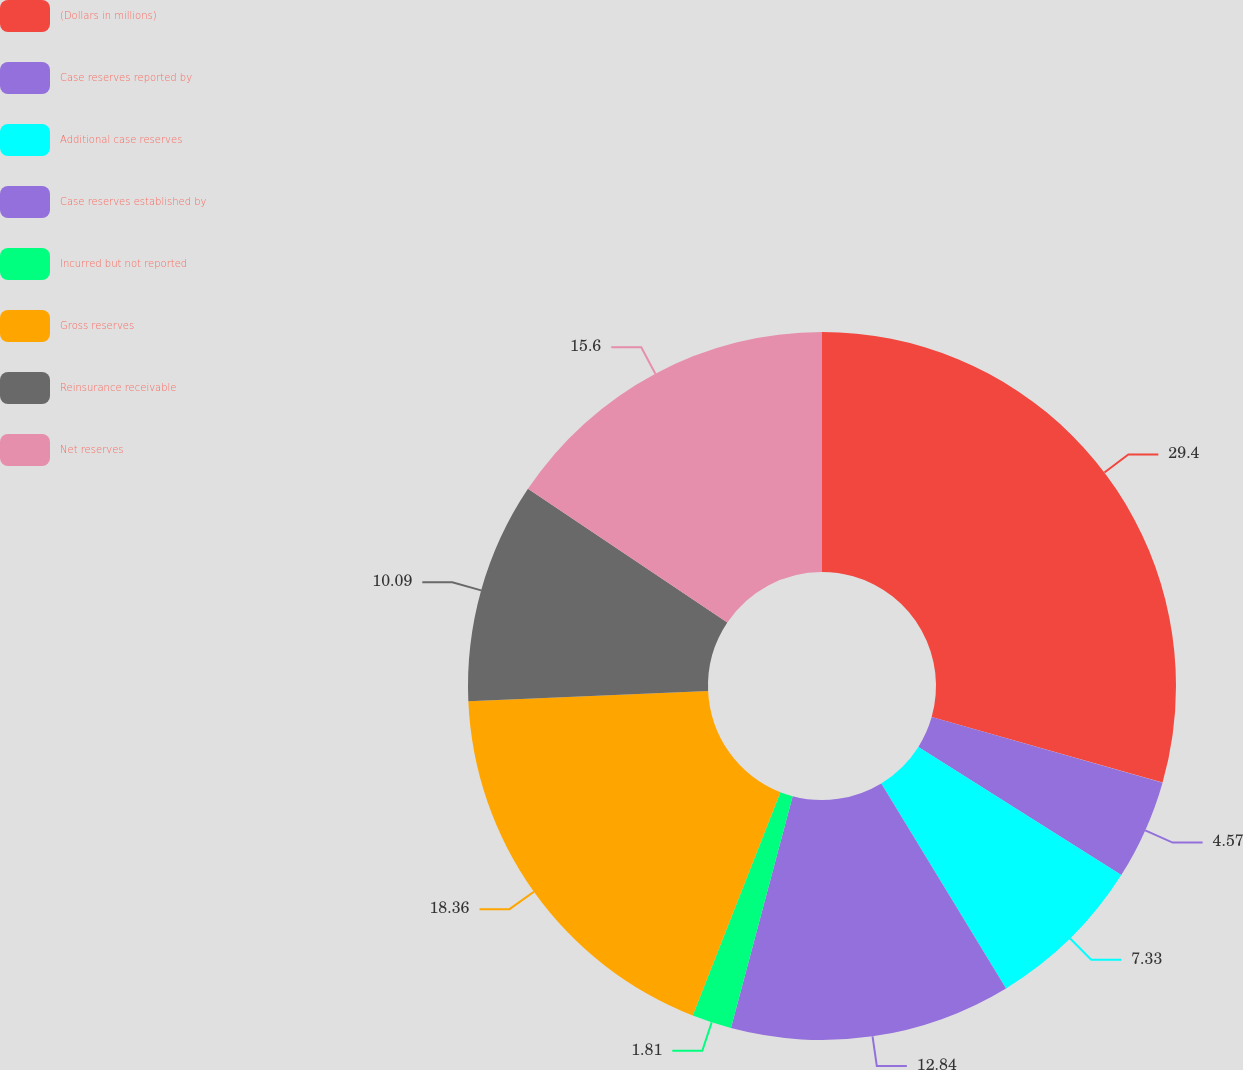<chart> <loc_0><loc_0><loc_500><loc_500><pie_chart><fcel>(Dollars in millions)<fcel>Case reserves reported by<fcel>Additional case reserves<fcel>Case reserves established by<fcel>Incurred but not reported<fcel>Gross reserves<fcel>Reinsurance receivable<fcel>Net reserves<nl><fcel>29.4%<fcel>4.57%<fcel>7.33%<fcel>12.84%<fcel>1.81%<fcel>18.36%<fcel>10.09%<fcel>15.6%<nl></chart> 